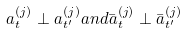<formula> <loc_0><loc_0><loc_500><loc_500>a _ { t } ^ { ( j ) } \perp a _ { t ^ { \prime } } ^ { ( j ) } a n d \bar { a } _ { t } ^ { ( j ) } \perp \bar { a } _ { t ^ { \prime } } ^ { ( j ) }</formula> 